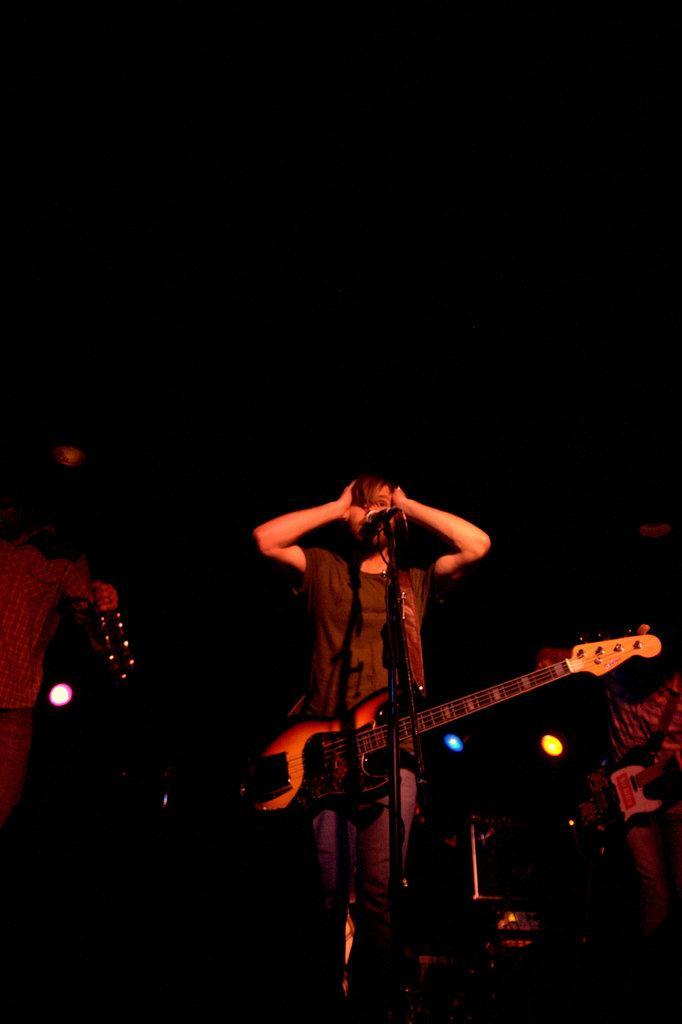Describe this image in one or two sentences. In the center of the image we can see a person standing. There is a guitar and we can see a mic placed on the stand. In the background there are people. 